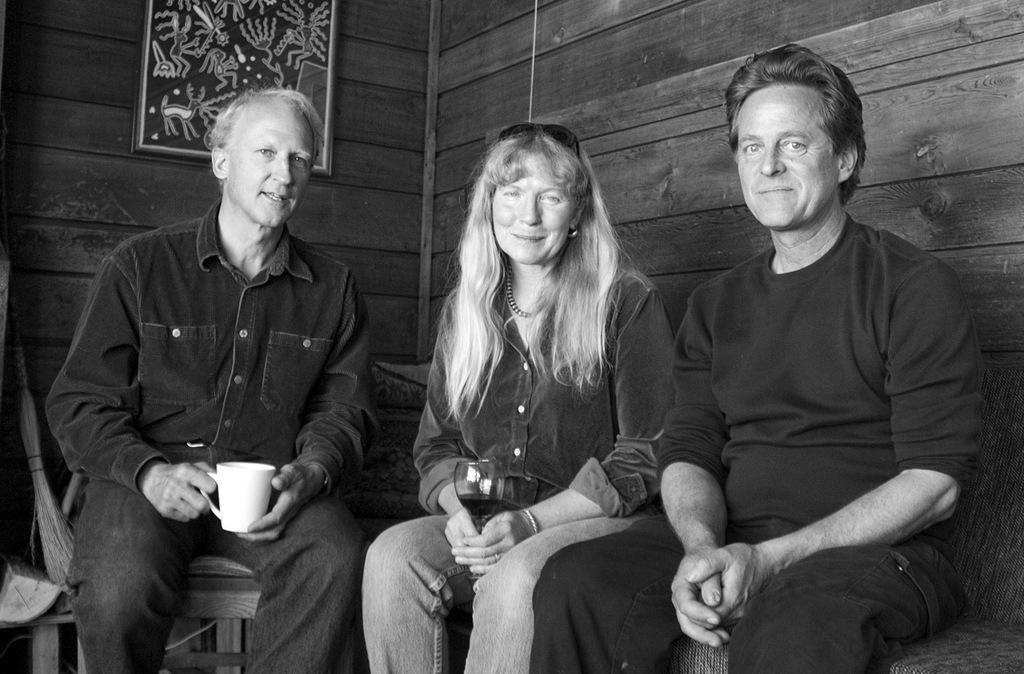Describe this image in one or two sentences. This is a black and white picture. Here we can see two men and a woman sitting on a bench. Woman is holding a wine glass in her hand and a man is holding a cup. On the background we can see a wooden wall and a frame on it. At the left side of the picture we can see a broomstick on a bench. 